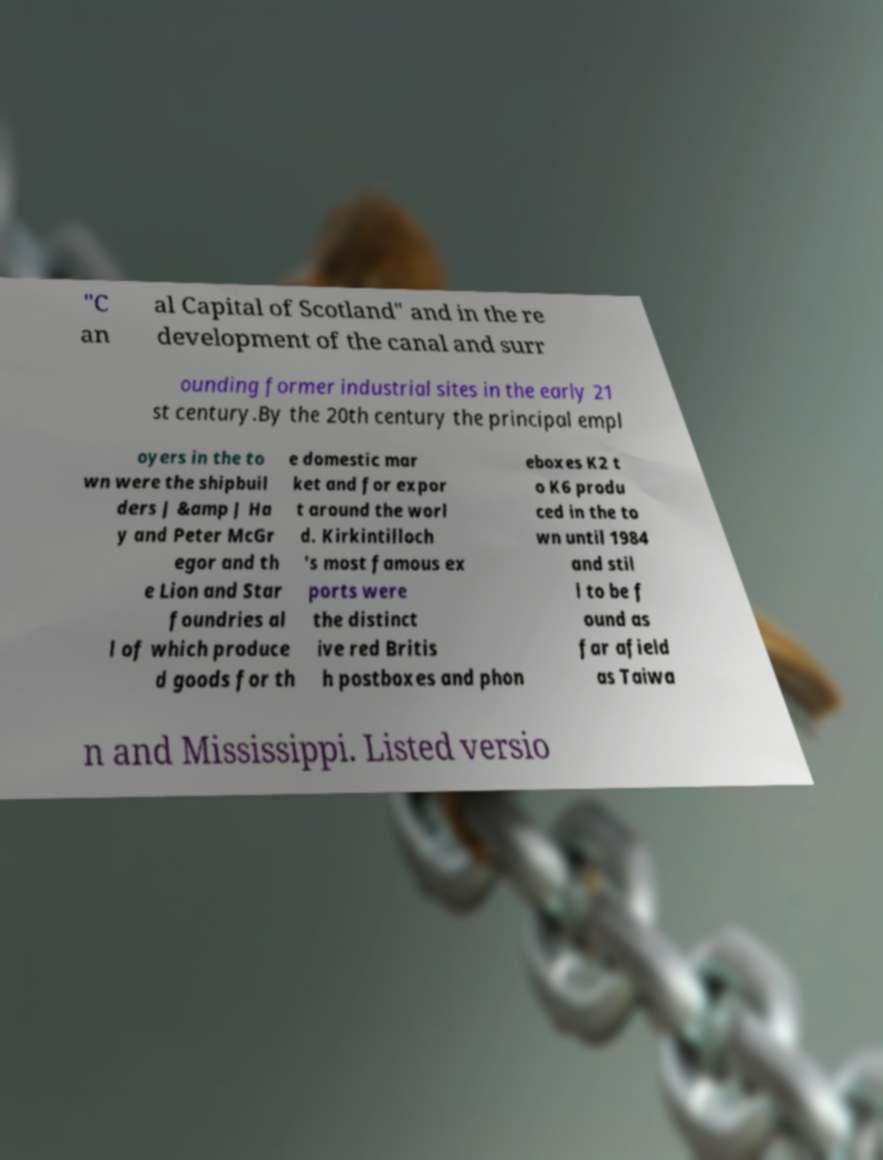I need the written content from this picture converted into text. Can you do that? "C an al Capital of Scotland" and in the re development of the canal and surr ounding former industrial sites in the early 21 st century.By the 20th century the principal empl oyers in the to wn were the shipbuil ders J &amp J Ha y and Peter McGr egor and th e Lion and Star foundries al l of which produce d goods for th e domestic mar ket and for expor t around the worl d. Kirkintilloch 's most famous ex ports were the distinct ive red Britis h postboxes and phon eboxes K2 t o K6 produ ced in the to wn until 1984 and stil l to be f ound as far afield as Taiwa n and Mississippi. Listed versio 